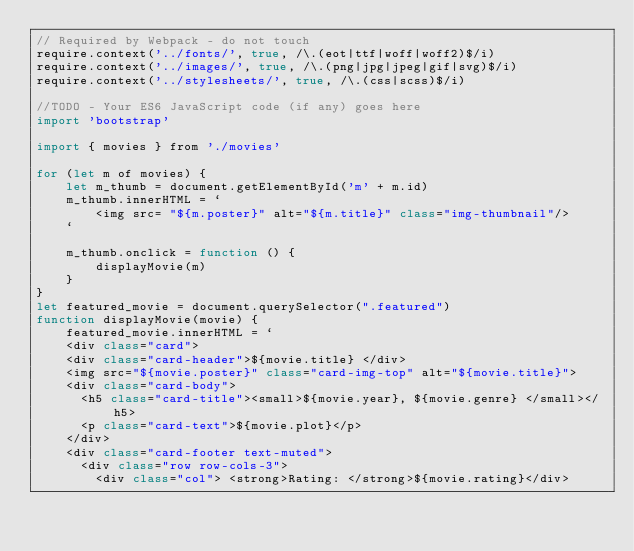<code> <loc_0><loc_0><loc_500><loc_500><_JavaScript_>// Required by Webpack - do not touch
require.context('../fonts/', true, /\.(eot|ttf|woff|woff2)$/i)
require.context('../images/', true, /\.(png|jpg|jpeg|gif|svg)$/i)
require.context('../stylesheets/', true, /\.(css|scss)$/i)

//TODO - Your ES6 JavaScript code (if any) goes here
import 'bootstrap'

import { movies } from './movies'

for (let m of movies) {
    let m_thumb = document.getElementById('m' + m.id)
    m_thumb.innerHTML = `
        <img src= "${m.poster}" alt="${m.title}" class="img-thumbnail"/>
    `

    m_thumb.onclick = function () {
        displayMovie(m)
    }
}
let featured_movie = document.querySelector(".featured")
function displayMovie(movie) {
    featured_movie.innerHTML = `
    <div class="card">
    <div class="card-header">${movie.title} </div>
    <img src="${movie.poster}" class="card-img-top" alt="${movie.title}">
    <div class="card-body">
      <h5 class="card-title"><small>${movie.year}, ${movie.genre} </small></h5>
      <p class="card-text">${movie.plot}</p>
    </div>
    <div class="card-footer text-muted">
      <div class="row row-cols-3">
        <div class="col"> <strong>Rating: </strong>${movie.rating}</div></code> 